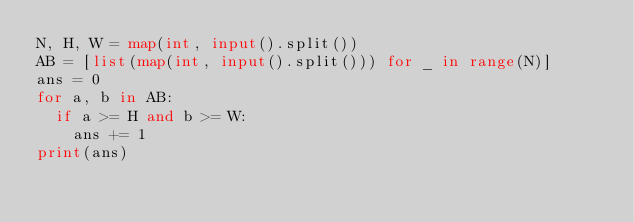Convert code to text. <code><loc_0><loc_0><loc_500><loc_500><_Python_>N, H, W = map(int, input().split())
AB = [list(map(int, input().split())) for _ in range(N)]
ans = 0
for a, b in AB:
  if a >= H and b >= W:
    ans += 1
print(ans)</code> 